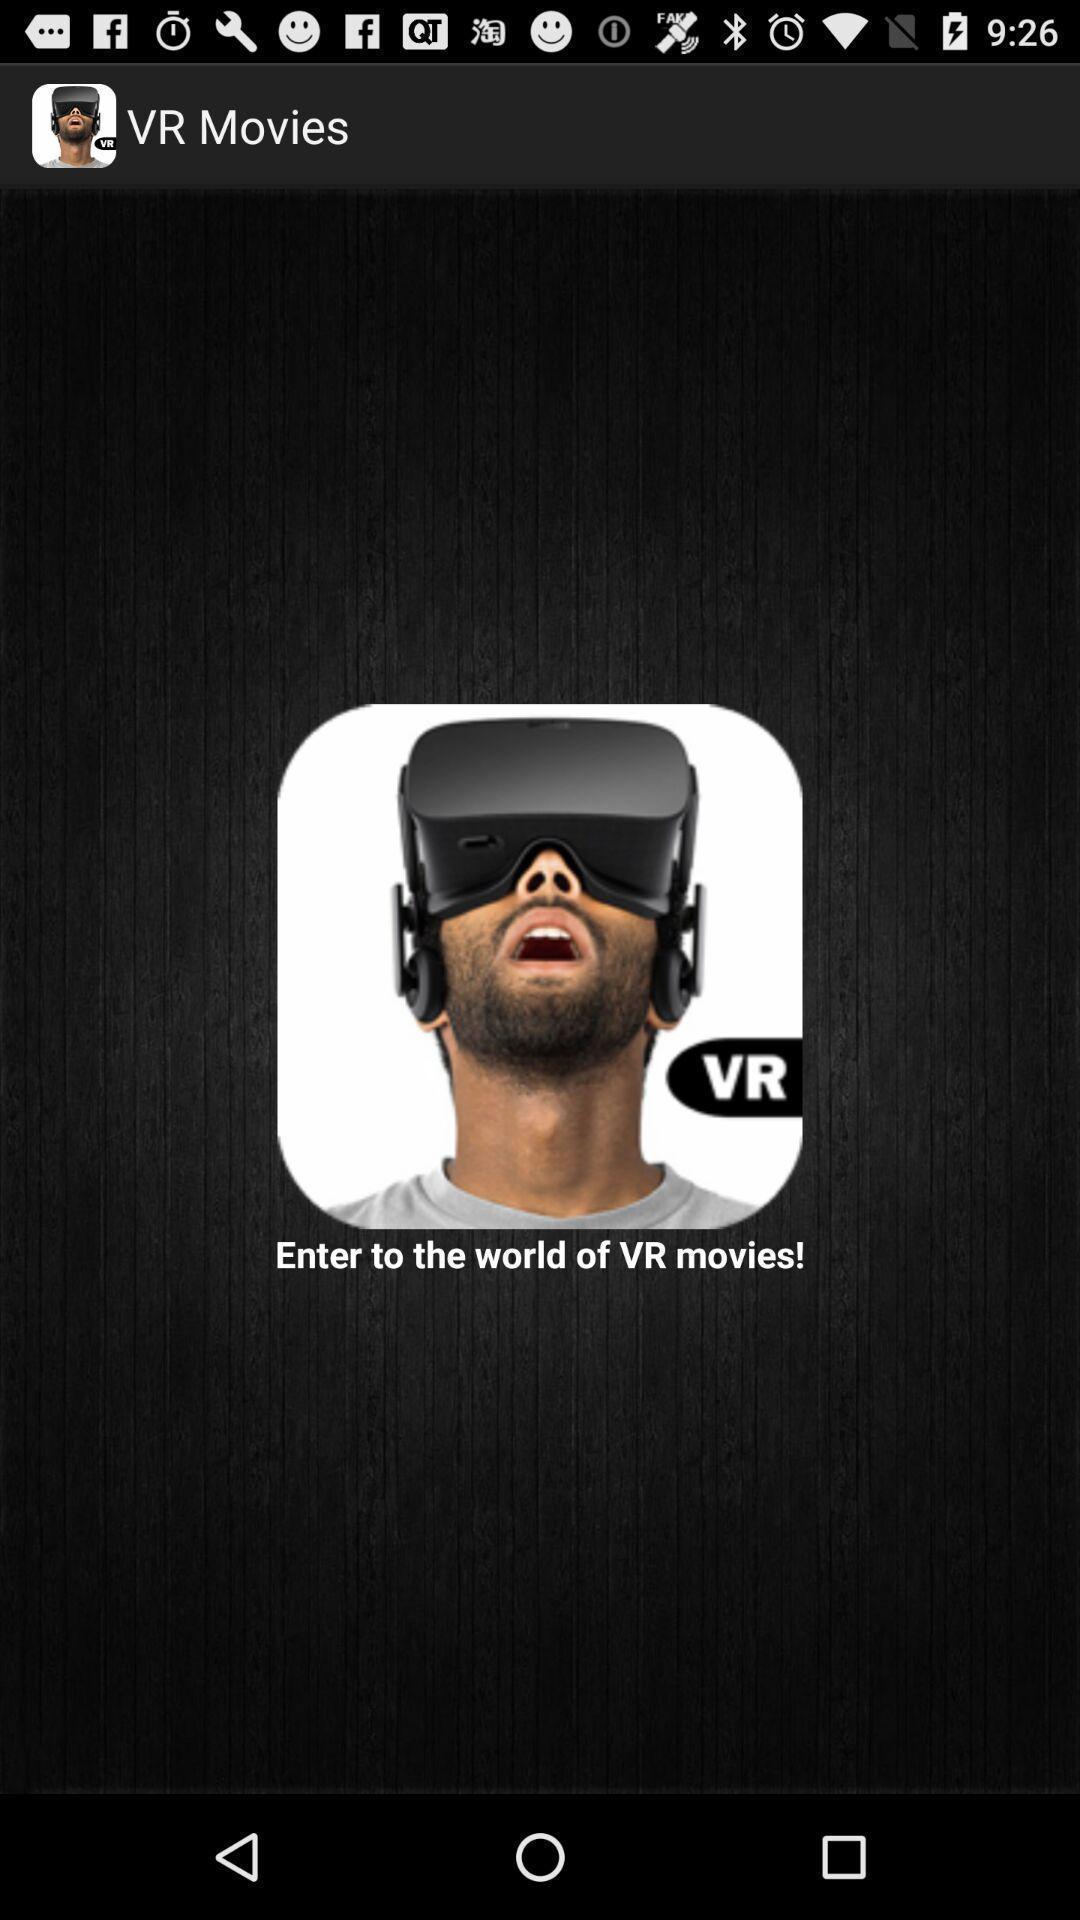Describe this image in words. Welcome page for movies application. 